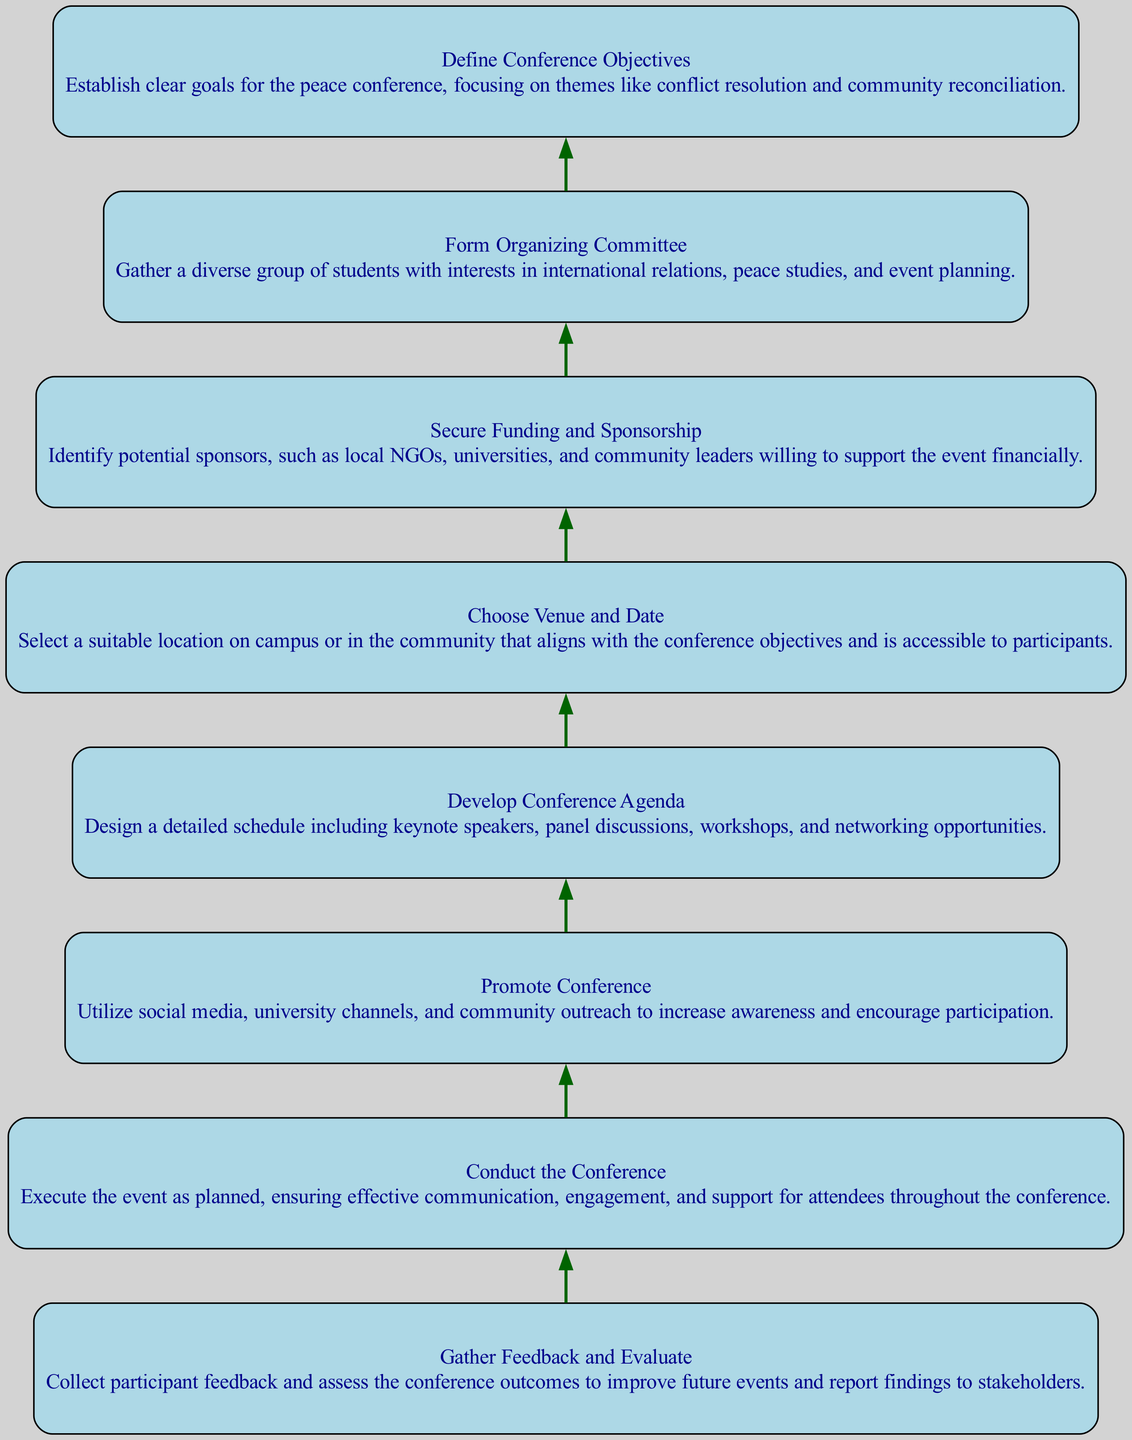What is the first step in organizing the conference? The first step, as shown in the diagram, is "Define Conference Objectives". This is identified as '1' and is positioned at the bottom of the flow chart, indicating it is the foundational element that leads to subsequent steps.
Answer: Define Conference Objectives How many elements are there in the diagram? By counting the individual nodes present in the diagram, we can see that there are a total of 8 elements related to the steps in organizing the conference. Each node corresponds to a specific step.
Answer: 8 Which step comes after "Secure Funding and Sponsorship"? The flow diagram indicates that after "Secure Funding and Sponsorship" which is represented by '3', the next step is "Choose Venue and Date", denoted by '4'. This connection follows the bottom-up structure outlined in the diagram.
Answer: Choose Venue and Date What is the main focus of the conference objectives? The description associated with "Define Conference Objectives" highlights that the focus should be on themes like "conflict resolution and community reconciliation". This emphasizes the thematic content of the intended discussions.
Answer: Conflict resolution and community reconciliation What is the last step described in the flow chart? The final step in the diagram is "Gather Feedback and Evaluate", which is represented by '8'. Being the last in the bottom-up flow indicates it follows all prior steps including the execution of the conference.
Answer: Gather Feedback and Evaluate Which node directly precedes "Conduct the Conference"? In the order shown in the flow chart, the step "Develop Conference Agenda" (denoted by '5') directly precedes "Conduct the Conference" (denoted by '7'), showcasing the sequential nature of preparation leading up to the event.
Answer: Develop Conference Agenda How is the "Promote Conference" step connected in the flow? The "Promote Conference" step (4) is connected by an edge to "Secure Funding and Sponsorship" (3) in the diagram. This shows that promoting the event follows ensuring financial support, highlighting the importance of funding in successful promotion.
Answer: Secure Funding and Sponsorship What description is associated with the "Gather Feedback and Evaluate" step? The node for "Gather Feedback and Evaluate" describes the need to "Collect participant feedback and assess the conference outcomes to improve future events..." This indicates the retrospective nature of this phase.
Answer: Collect participant feedback and assess the conference outcomes to improve future events 